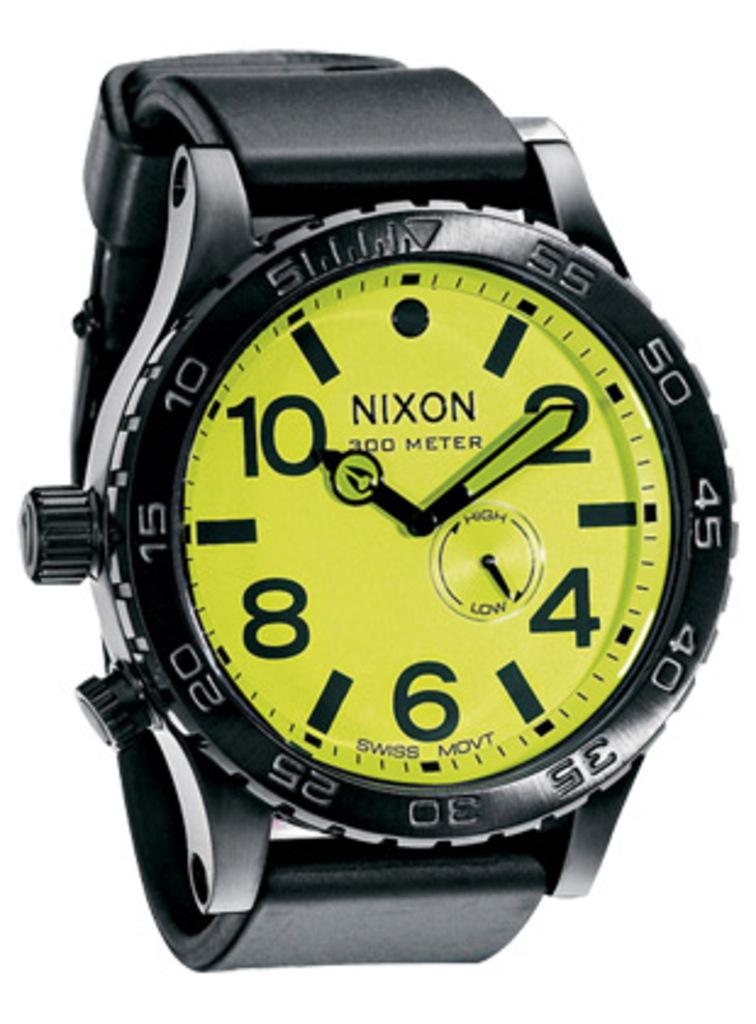<image>
Write a terse but informative summary of the picture. The watch here has a movement called the Swiss movement 